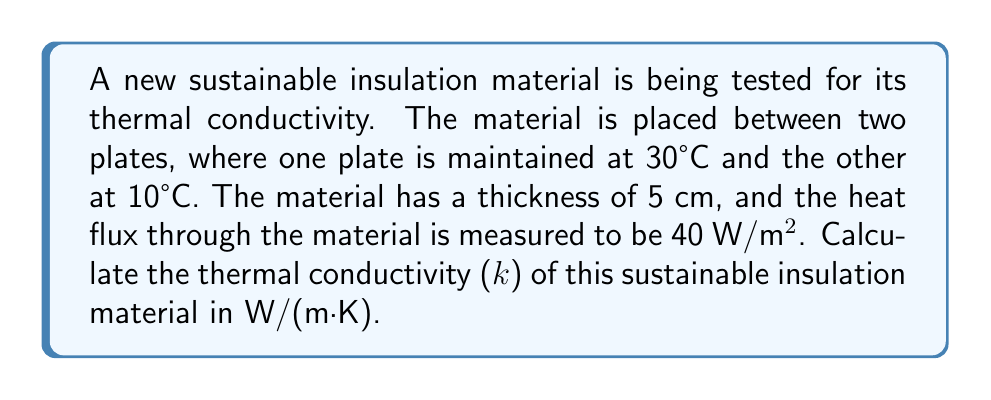Give your solution to this math problem. To calculate the thermal conductivity of the insulation material, we'll use Fourier's Law of Heat Conduction:

$$q = -k \frac{dT}{dx}$$

Where:
$q$ = heat flux (W/m²)
$k$ = thermal conductivity (W/(m·K))
$\frac{dT}{dx}$ = temperature gradient (K/m)

Step 1: Identify the known values
- Heat flux, $q = 40$ W/m²
- Temperature difference, $\Delta T = 30°C - 10°C = 20°C = 20$ K
- Thickness, $\Delta x = 5$ cm $= 0.05$ m

Step 2: Calculate the temperature gradient
$$\frac{dT}{dx} = \frac{\Delta T}{\Delta x} = \frac{20 \text{ K}}{0.05 \text{ m}} = 400 \text{ K/m}$$

Step 3: Rearrange Fourier's Law to solve for k
$$k = -\frac{q}{\frac{dT}{dx}}$$

Step 4: Substitute the values and calculate k
$$k = -\frac{40 \text{ W/m²}}{400 \text{ K/m}} = -0.1 \text{ W/(m·K)}$$

Step 5: Take the absolute value of k (since thermal conductivity is always positive)
$$k = 0.1 \text{ W/(m·K)}$$
Answer: 0.1 W/(m·K) 